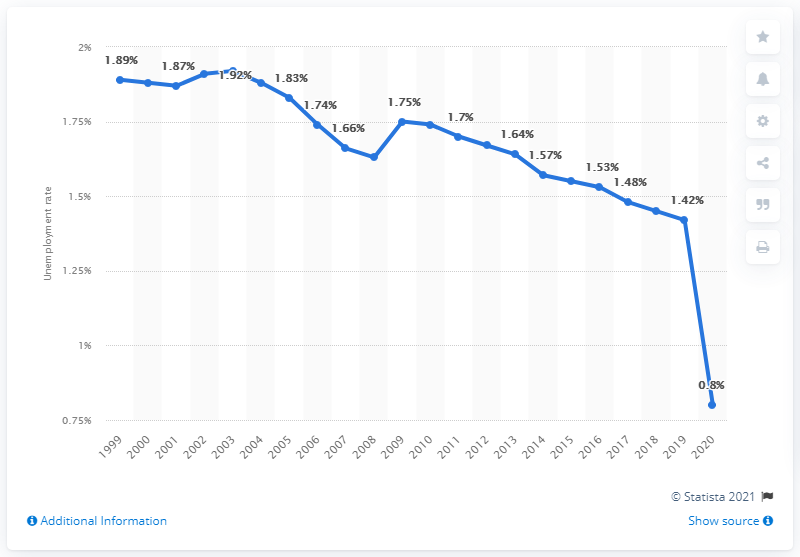Draw attention to some important aspects in this diagram. In 2020, the unemployment rate in Burundi was 0.8%. 